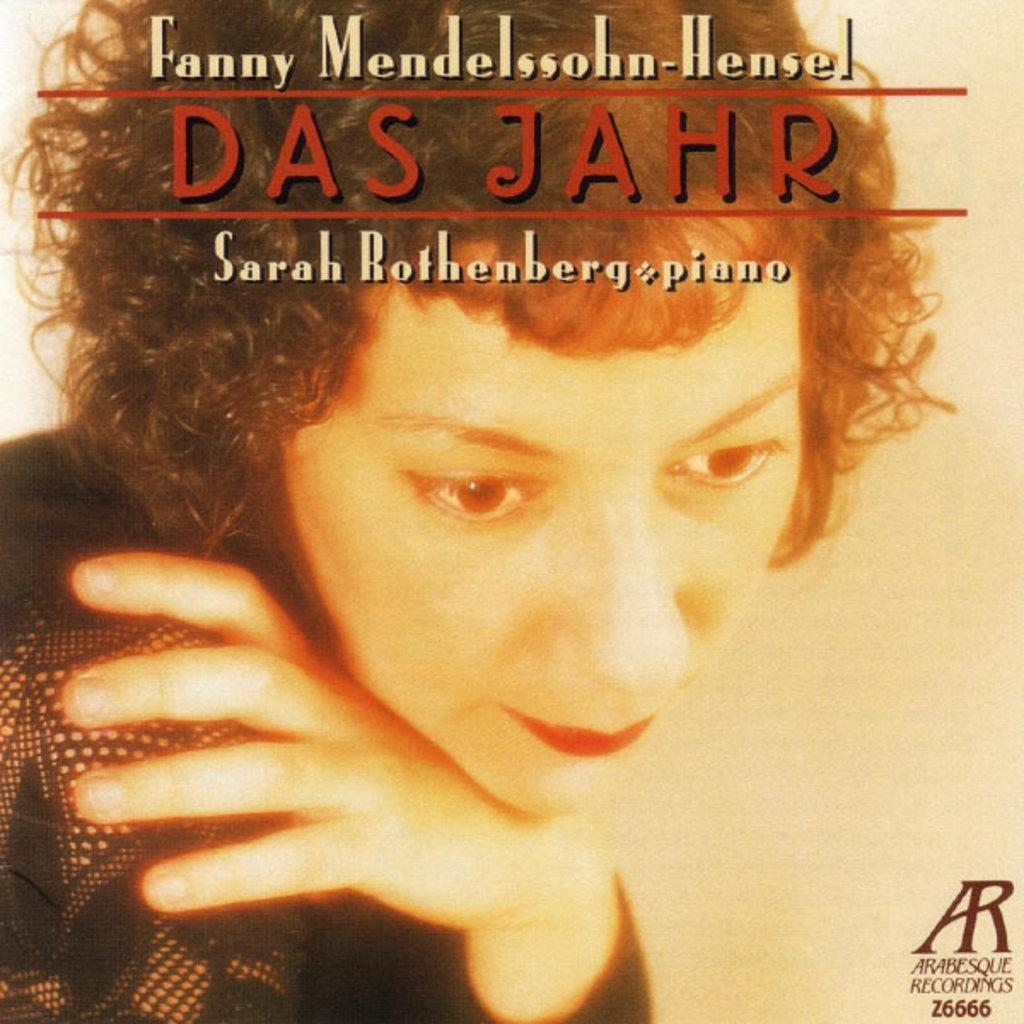What is featured on the poster in the image? The poster contains a person. What else can be seen on the poster besides the person? There is text on the poster. Can you describe the person in the image who is not on the poster? There is a person wearing a black shirt in the image. Where is text located in the image? There is text at the top of the image and at the right bottom of the image. How many rabbits can be seen playing in the land in the image? There are no rabbits or land present in the image; it features a poster with a person and text, as well as a person wearing a black shirt. What type of space vehicle is visible in the image? There is no space vehicle present in the image. 